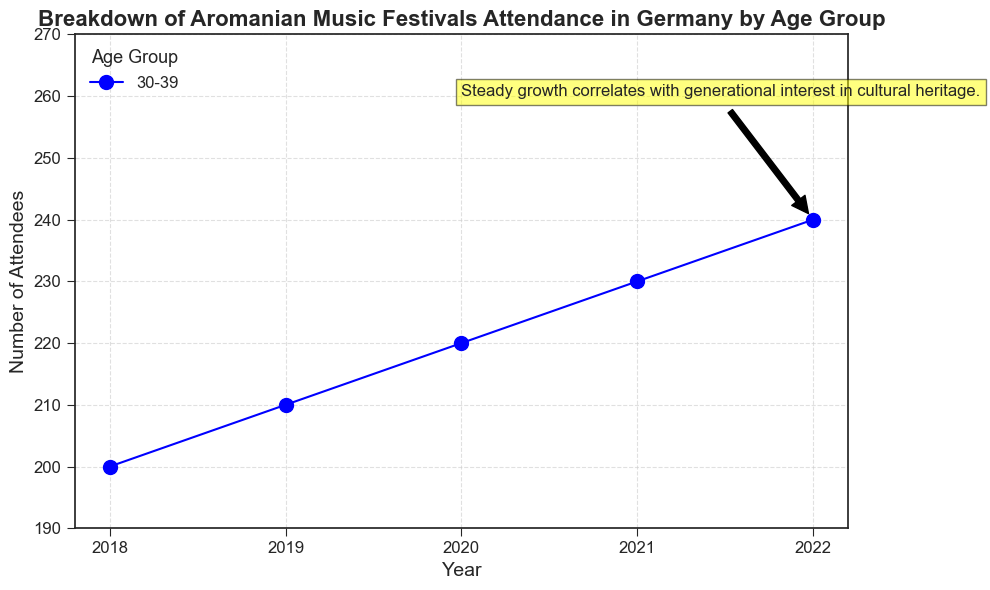What is the overall trend in attendance for the 30-39 age group from 2018 to 2022? The plot shows a continuous increase in the number of attendees for the 30-39 age group from 2018 to 2022, as indicated by the marker points moving upwards each year.
Answer: Steady growth By how many attendees did the number increase from 2018 to 2022 in the 30-39 age group? In 2018, there were 200 attendees, and in 2022, there were 240 attendees. So, the increase is 240 - 200 = 40 attendees.
Answer: 40 What can you infer from the trend annotation about the increase in attendance? The trend annotation indicates, "Steady growth correlates with generational interest in cultural heritage." This suggests that the increasing attendance may be due to a growing interest in cultural heritage among the 30-39 age group.
Answer: Interest in cultural heritage Compare the number of attendees in 2019 and 2020 for the 30-39 age group. Which year had higher attendance and by how much? In 2019, the attendance was 210, and in 2020, it was 220. 2020 had higher attendance by 220 - 210 = 10 attendees.
Answer: 2020 by 10 What visual clue on the plot indicates that the attendance in 2022 was the highest over the years? The plot shows the highest marker point in 2022, which visually indicates the peak attendance among the plotted years.
Answer: Highest marker point in 2022 Which year shows the least number of attendees for the 30-39 age group? By looking at the plot, 2018 shows the lowest marker point, indicating the least number of attendees.
Answer: 2018 Calculate the average attendance over the years 2018 to 2022 for the 30-39 age group. Sum the attendance from 2018 to 2022: 200 + 210 + 220 + 230 + 240 = 1100. Then divide by 5 years to get 1100/5 = 220 attendees.
Answer: 220 What does the arrow in the annotation point to, and what does it signify? The arrow in the annotation points to the marker representing 2022 attendance, signifying the end point of the steady growth mentioned in the annotation.
Answer: 2022 attendance If the trend continues, estimate the attendance for 2023 for the 30-39 age group. Based on the steady growth trend, where attendance increases by approximately 10 attendees each year, the estimated attendance for 2023 would be 240 + 10 = 250 attendees.
Answer: 250 